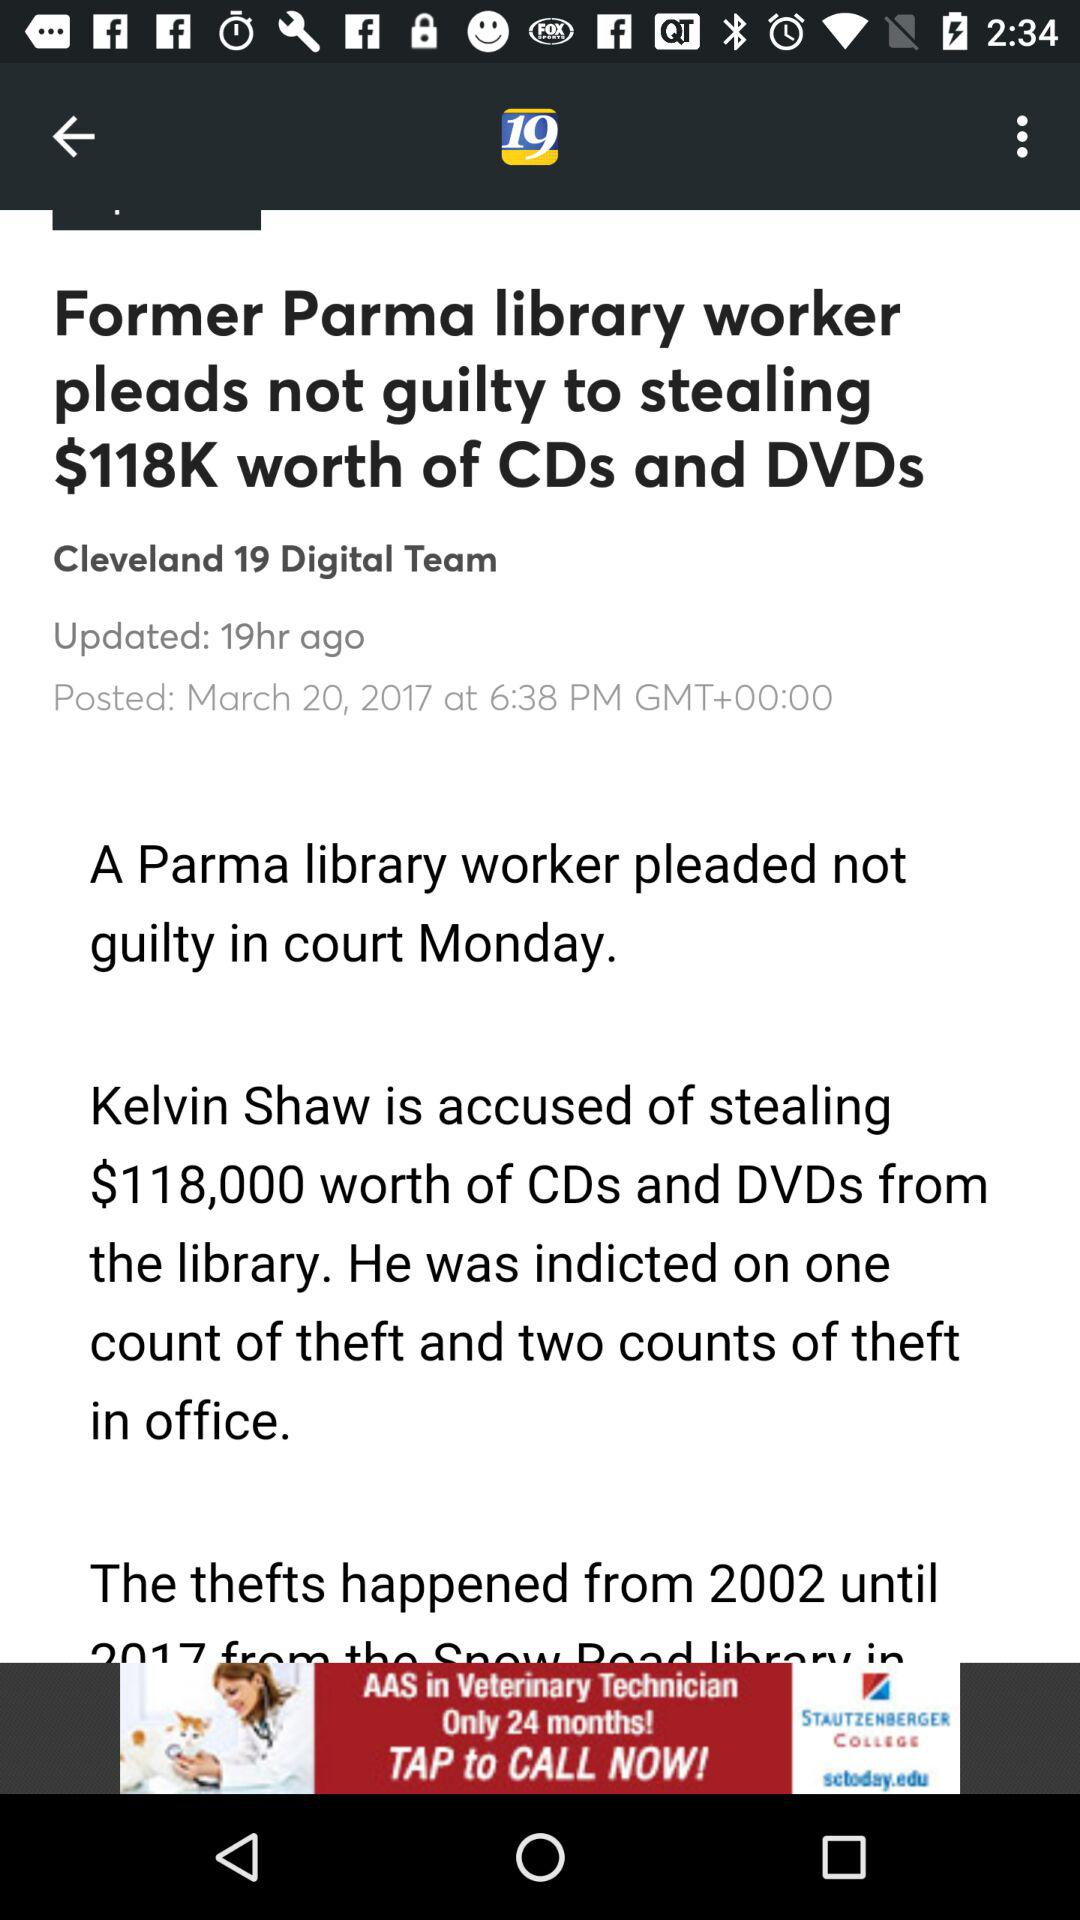How many years did the thefts last?
Answer the question using a single word or phrase. 15 